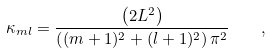Convert formula to latex. <formula><loc_0><loc_0><loc_500><loc_500>\kappa _ { m l } = \frac { \left ( 2 L ^ { 2 } \right ) } { \left ( ( m + 1 ) ^ { 2 } + ( l + 1 ) ^ { 2 } \right ) \pi ^ { 2 } } \quad ,</formula> 